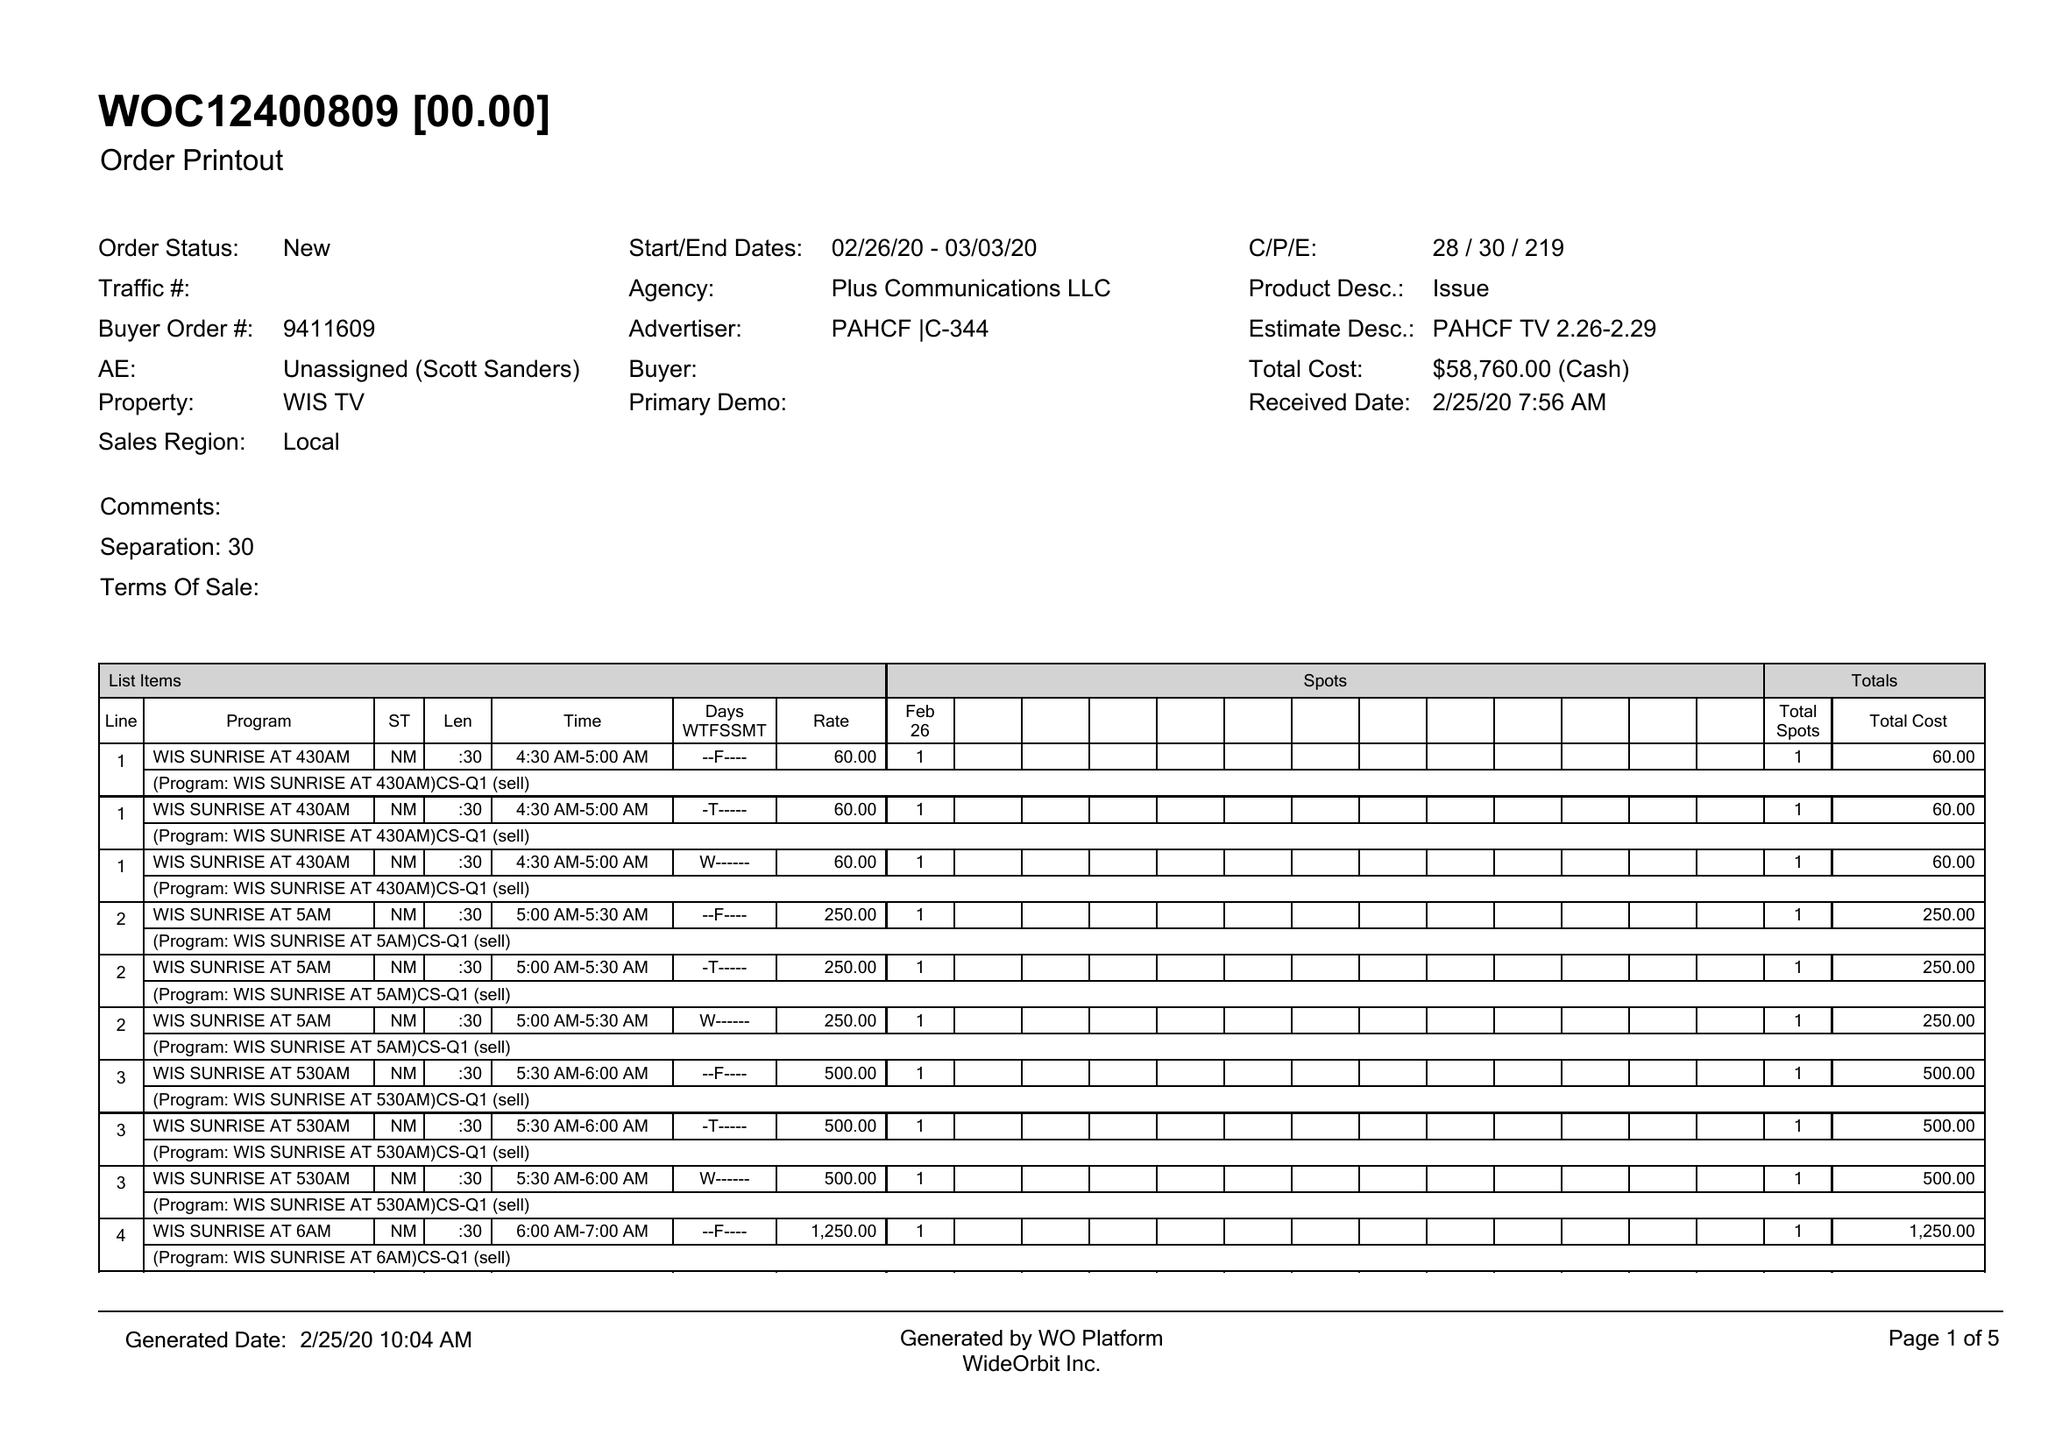What is the value for the flight_to?
Answer the question using a single word or phrase. 03/03/20 